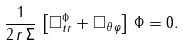<formula> <loc_0><loc_0><loc_500><loc_500>\frac { 1 } { 2 \, r \, \Sigma } \, \left [ { \square } ^ { \Phi } _ { t r } + \square _ { \theta \, \varphi } \right ] \, \Phi = 0 .</formula> 